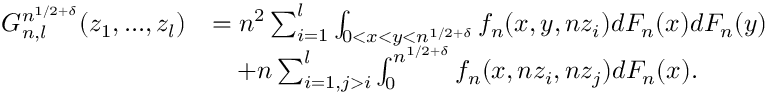Convert formula to latex. <formula><loc_0><loc_0><loc_500><loc_500>\begin{array} { r l } { G _ { n , l } ^ { n ^ { 1 / 2 + \delta } } ( z _ { 1 } , \dots , z _ { l } ) } & { = n ^ { 2 } \sum _ { i = 1 } ^ { l } \int _ { 0 < x < y < n ^ { 1 / 2 + \delta } } f _ { n } ( x , y , n z _ { i } ) d F _ { n } ( x ) d F _ { n } ( y ) } \\ & { \quad + n \sum _ { i = 1 , j > i } ^ { l } \int _ { 0 } ^ { n ^ { 1 / 2 + \delta } } f _ { n } ( x , n z _ { i } , n z _ { j } ) d F _ { n } ( x ) . } \end{array}</formula> 